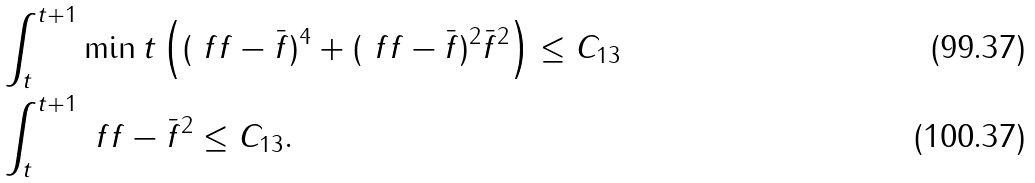Convert formula to latex. <formula><loc_0><loc_0><loc_500><loc_500>& \int _ { t } ^ { t + 1 } \min t \left ( ( \ f f - \bar { f } ) ^ { 4 } + ( \ f f - \bar { f } ) ^ { 2 } \bar { f } ^ { 2 } \right ) \leq C _ { 1 3 } \\ & \int _ { t } ^ { t + 1 } \| \ f f - \bar { f } \| ^ { 2 } \leq C _ { 1 3 } .</formula> 